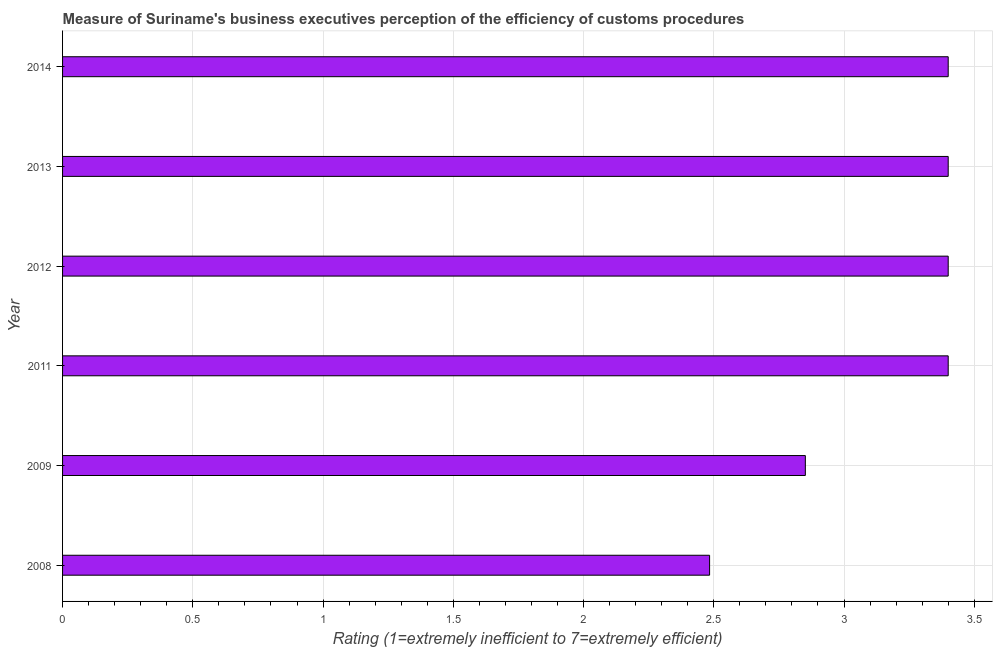Does the graph contain any zero values?
Your response must be concise. No. What is the title of the graph?
Offer a terse response. Measure of Suriname's business executives perception of the efficiency of customs procedures. What is the label or title of the X-axis?
Provide a short and direct response. Rating (1=extremely inefficient to 7=extremely efficient). What is the rating measuring burden of customs procedure in 2009?
Offer a very short reply. 2.85. Across all years, what is the minimum rating measuring burden of customs procedure?
Ensure brevity in your answer.  2.48. In which year was the rating measuring burden of customs procedure minimum?
Your answer should be very brief. 2008. What is the sum of the rating measuring burden of customs procedure?
Your answer should be very brief. 18.94. What is the difference between the rating measuring burden of customs procedure in 2008 and 2011?
Your answer should be compact. -0.92. What is the average rating measuring burden of customs procedure per year?
Offer a terse response. 3.16. Do a majority of the years between 2008 and 2012 (inclusive) have rating measuring burden of customs procedure greater than 2.3 ?
Make the answer very short. Yes. What is the ratio of the rating measuring burden of customs procedure in 2009 to that in 2013?
Provide a short and direct response. 0.84. Is the difference between the rating measuring burden of customs procedure in 2008 and 2011 greater than the difference between any two years?
Provide a short and direct response. Yes. Is the sum of the rating measuring burden of customs procedure in 2009 and 2013 greater than the maximum rating measuring burden of customs procedure across all years?
Make the answer very short. Yes. What is the difference between the highest and the lowest rating measuring burden of customs procedure?
Give a very brief answer. 0.92. In how many years, is the rating measuring burden of customs procedure greater than the average rating measuring burden of customs procedure taken over all years?
Your answer should be compact. 4. How many bars are there?
Your response must be concise. 6. Are all the bars in the graph horizontal?
Offer a very short reply. Yes. What is the difference between two consecutive major ticks on the X-axis?
Provide a succinct answer. 0.5. What is the Rating (1=extremely inefficient to 7=extremely efficient) in 2008?
Provide a succinct answer. 2.48. What is the Rating (1=extremely inefficient to 7=extremely efficient) of 2009?
Your response must be concise. 2.85. What is the Rating (1=extremely inefficient to 7=extremely efficient) of 2011?
Keep it short and to the point. 3.4. What is the Rating (1=extremely inefficient to 7=extremely efficient) in 2012?
Your response must be concise. 3.4. What is the Rating (1=extremely inefficient to 7=extremely efficient) of 2013?
Offer a very short reply. 3.4. What is the Rating (1=extremely inefficient to 7=extremely efficient) of 2014?
Provide a short and direct response. 3.4. What is the difference between the Rating (1=extremely inefficient to 7=extremely efficient) in 2008 and 2009?
Provide a succinct answer. -0.37. What is the difference between the Rating (1=extremely inefficient to 7=extremely efficient) in 2008 and 2011?
Your answer should be very brief. -0.92. What is the difference between the Rating (1=extremely inefficient to 7=extremely efficient) in 2008 and 2012?
Offer a terse response. -0.92. What is the difference between the Rating (1=extremely inefficient to 7=extremely efficient) in 2008 and 2013?
Provide a succinct answer. -0.92. What is the difference between the Rating (1=extremely inefficient to 7=extremely efficient) in 2008 and 2014?
Your response must be concise. -0.92. What is the difference between the Rating (1=extremely inefficient to 7=extremely efficient) in 2009 and 2011?
Provide a short and direct response. -0.55. What is the difference between the Rating (1=extremely inefficient to 7=extremely efficient) in 2009 and 2012?
Your answer should be compact. -0.55. What is the difference between the Rating (1=extremely inefficient to 7=extremely efficient) in 2009 and 2013?
Provide a short and direct response. -0.55. What is the difference between the Rating (1=extremely inefficient to 7=extremely efficient) in 2009 and 2014?
Provide a short and direct response. -0.55. What is the difference between the Rating (1=extremely inefficient to 7=extremely efficient) in 2011 and 2014?
Offer a terse response. 0. What is the ratio of the Rating (1=extremely inefficient to 7=extremely efficient) in 2008 to that in 2009?
Provide a succinct answer. 0.87. What is the ratio of the Rating (1=extremely inefficient to 7=extremely efficient) in 2008 to that in 2011?
Make the answer very short. 0.73. What is the ratio of the Rating (1=extremely inefficient to 7=extremely efficient) in 2008 to that in 2012?
Make the answer very short. 0.73. What is the ratio of the Rating (1=extremely inefficient to 7=extremely efficient) in 2008 to that in 2013?
Ensure brevity in your answer.  0.73. What is the ratio of the Rating (1=extremely inefficient to 7=extremely efficient) in 2008 to that in 2014?
Offer a very short reply. 0.73. What is the ratio of the Rating (1=extremely inefficient to 7=extremely efficient) in 2009 to that in 2011?
Provide a short and direct response. 0.84. What is the ratio of the Rating (1=extremely inefficient to 7=extremely efficient) in 2009 to that in 2012?
Keep it short and to the point. 0.84. What is the ratio of the Rating (1=extremely inefficient to 7=extremely efficient) in 2009 to that in 2013?
Offer a terse response. 0.84. What is the ratio of the Rating (1=extremely inefficient to 7=extremely efficient) in 2009 to that in 2014?
Keep it short and to the point. 0.84. What is the ratio of the Rating (1=extremely inefficient to 7=extremely efficient) in 2011 to that in 2014?
Your response must be concise. 1. 